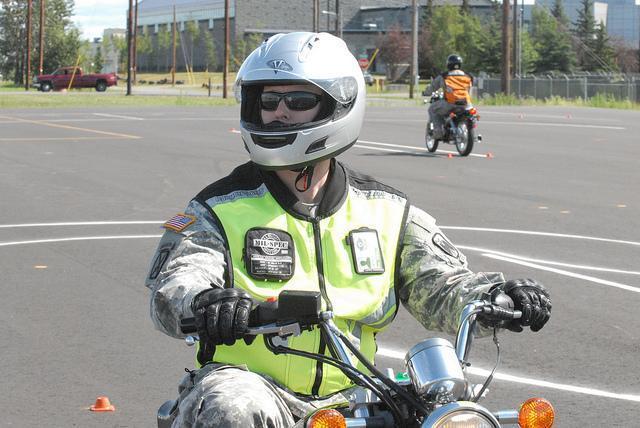How many people are there?
Give a very brief answer. 2. 